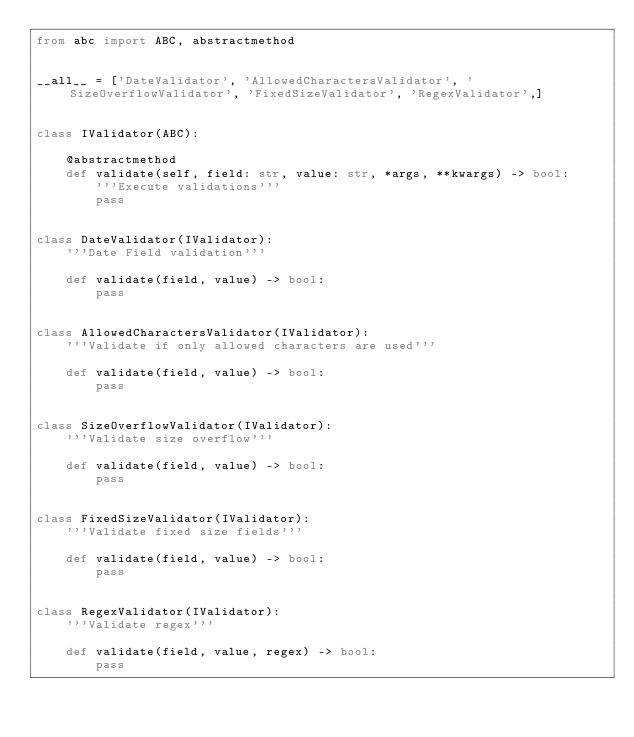Convert code to text. <code><loc_0><loc_0><loc_500><loc_500><_Python_>from abc import ABC, abstractmethod


__all__ = ['DateValidator', 'AllowedCharactersValidator', 'SizeOverflowValidator', 'FixedSizeValidator', 'RegexValidator',]


class IValidator(ABC):

    @abstractmethod
    def validate(self, field: str, value: str, *args, **kwargs) -> bool:
        '''Execute validations'''
        pass


class DateValidator(IValidator):
    '''Date Field validation'''

    def validate(field, value) -> bool:
        pass


class AllowedCharactersValidator(IValidator):
    '''Validate if only allowed characters are used'''

    def validate(field, value) -> bool:
        pass


class SizeOverflowValidator(IValidator):
    '''Validate size overflow'''

    def validate(field, value) -> bool:
        pass


class FixedSizeValidator(IValidator):
    '''Validate fixed size fields'''

    def validate(field, value) -> bool:
        pass


class RegexValidator(IValidator):
    '''Validate regex'''

    def validate(field, value, regex) -> bool:
        pass</code> 